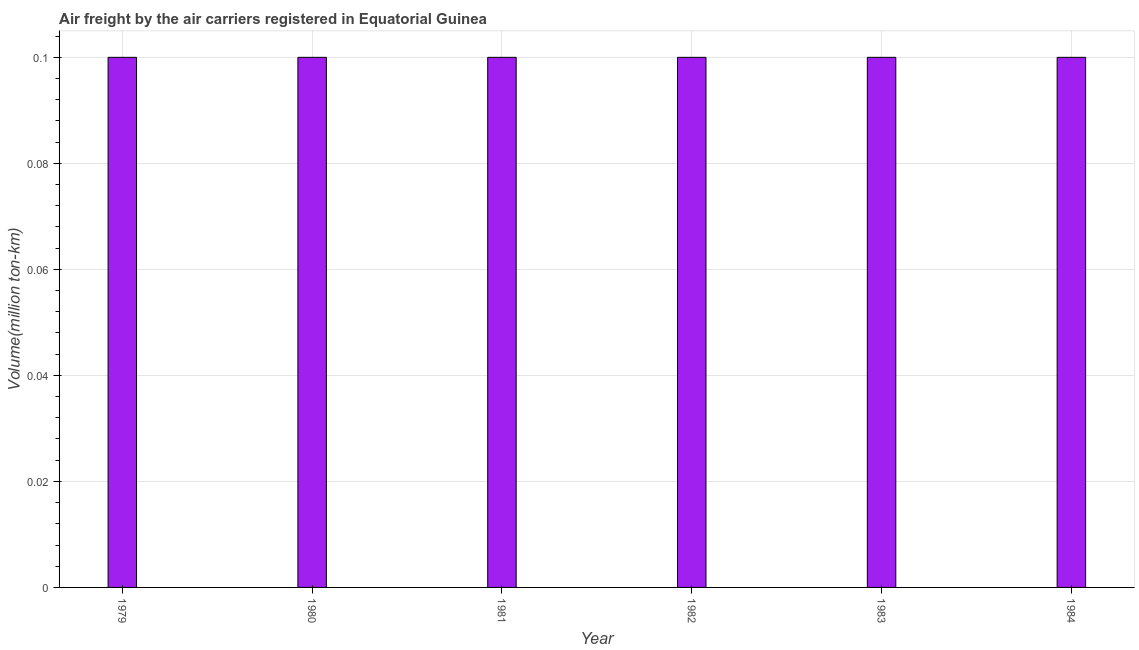Does the graph contain grids?
Your answer should be very brief. Yes. What is the title of the graph?
Keep it short and to the point. Air freight by the air carriers registered in Equatorial Guinea. What is the label or title of the X-axis?
Provide a short and direct response. Year. What is the label or title of the Y-axis?
Provide a short and direct response. Volume(million ton-km). What is the air freight in 1982?
Provide a short and direct response. 0.1. Across all years, what is the maximum air freight?
Your answer should be compact. 0.1. Across all years, what is the minimum air freight?
Make the answer very short. 0.1. In which year was the air freight maximum?
Provide a succinct answer. 1979. In which year was the air freight minimum?
Your answer should be very brief. 1979. What is the sum of the air freight?
Give a very brief answer. 0.6. What is the median air freight?
Your answer should be very brief. 0.1. Do a majority of the years between 1984 and 1979 (inclusive) have air freight greater than 0.096 million ton-km?
Offer a very short reply. Yes. Is the difference between the air freight in 1982 and 1984 greater than the difference between any two years?
Ensure brevity in your answer.  Yes. What is the difference between the highest and the second highest air freight?
Ensure brevity in your answer.  0. What is the difference between the highest and the lowest air freight?
Your response must be concise. 0. What is the difference between two consecutive major ticks on the Y-axis?
Provide a short and direct response. 0.02. Are the values on the major ticks of Y-axis written in scientific E-notation?
Keep it short and to the point. No. What is the Volume(million ton-km) in 1979?
Offer a very short reply. 0.1. What is the Volume(million ton-km) in 1980?
Offer a terse response. 0.1. What is the Volume(million ton-km) in 1981?
Give a very brief answer. 0.1. What is the Volume(million ton-km) in 1982?
Give a very brief answer. 0.1. What is the Volume(million ton-km) of 1983?
Offer a very short reply. 0.1. What is the Volume(million ton-km) of 1984?
Provide a succinct answer. 0.1. What is the difference between the Volume(million ton-km) in 1979 and 1981?
Offer a very short reply. 0. What is the difference between the Volume(million ton-km) in 1979 and 1982?
Keep it short and to the point. 0. What is the difference between the Volume(million ton-km) in 1979 and 1983?
Offer a terse response. 0. What is the difference between the Volume(million ton-km) in 1979 and 1984?
Provide a succinct answer. 0. What is the difference between the Volume(million ton-km) in 1980 and 1981?
Your response must be concise. 0. What is the difference between the Volume(million ton-km) in 1980 and 1982?
Provide a succinct answer. 0. What is the difference between the Volume(million ton-km) in 1980 and 1983?
Your answer should be compact. 0. What is the difference between the Volume(million ton-km) in 1980 and 1984?
Provide a succinct answer. 0. What is the difference between the Volume(million ton-km) in 1981 and 1982?
Your answer should be very brief. 0. What is the difference between the Volume(million ton-km) in 1981 and 1983?
Provide a succinct answer. 0. What is the difference between the Volume(million ton-km) in 1981 and 1984?
Give a very brief answer. 0. What is the difference between the Volume(million ton-km) in 1983 and 1984?
Your response must be concise. 0. What is the ratio of the Volume(million ton-km) in 1979 to that in 1980?
Provide a short and direct response. 1. What is the ratio of the Volume(million ton-km) in 1979 to that in 1981?
Keep it short and to the point. 1. What is the ratio of the Volume(million ton-km) in 1979 to that in 1984?
Your answer should be very brief. 1. What is the ratio of the Volume(million ton-km) in 1980 to that in 1982?
Make the answer very short. 1. What is the ratio of the Volume(million ton-km) in 1980 to that in 1984?
Provide a short and direct response. 1. What is the ratio of the Volume(million ton-km) in 1982 to that in 1983?
Your answer should be very brief. 1. What is the ratio of the Volume(million ton-km) in 1983 to that in 1984?
Give a very brief answer. 1. 